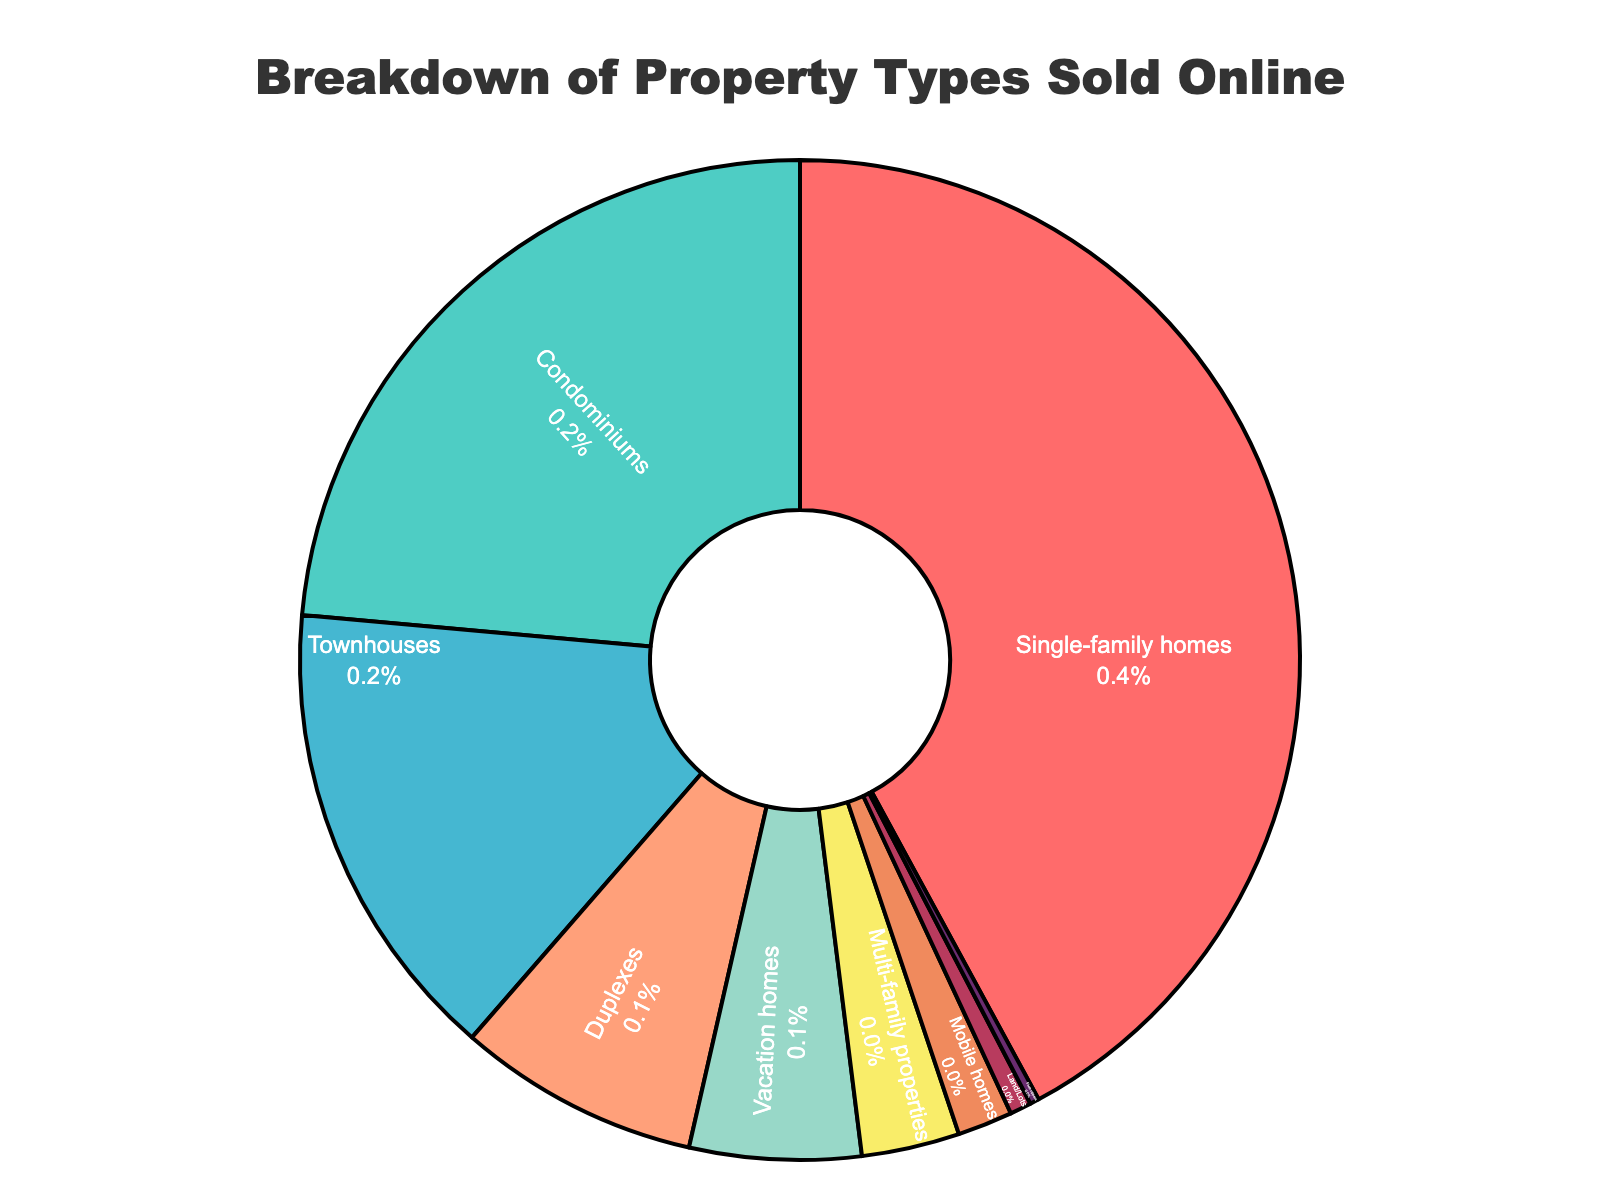What percentage of the total properties sold are Single-family homes and Townhouses combined? The percentage of Single-family homes is 42.5%, and Townhouses is 15.2%. By adding these two percentages, we get 42.5 + 15.2 = 57.7%.
Answer: 57.7% Which property type has the smallest percentage share? By looking at the pie chart, the segment for Fixer-uppers is the smallest, making it the property type with the smallest percentage share at 0.3%.
Answer: Fixer-uppers How does the percentage of Condominiums compare to that of Mobile homes? The percentage of Condominiums is 23.8%, while Mobile homes have 1.8%. Comparing these, 23.8% is significantly greater than 1.8%.
Answer: Condominiums have a higher percentage than Mobile homes What is the combined percentage of Duplexes, Vacation homes, and Multi-family properties? Duplexes represent 7.9%, Vacation homes represent 5.6%, and Multi-family properties represent 3.2%. Adding these together gives 7.9 + 5.6 + 3.2 = 16.7%.
Answer: 16.7% Which property type is represented by the blue color in the pie chart? The pie chart segments are identified by Property Types and colors. The blue segment corresponds to Condominiums.
Answer: Condominiums Do Single-family homes and Condominiums together make up more than 50% of the total properties sold? Single-family homes account for 42.5%, and Condominiums account for 23.8%. Adding these together gives 42.5 + 23.8 = 66.3%, which is more than 50%.
Answer: Yes, they make up more than 50% Which two property types have the nearest percentage values to each other? From the pie chart, Vacation homes (5.6%) and Multi-family properties (3.2%) have fairly close percentage values. However, Duplexes (7.9%) and Vacation homes (5.6%) are closer if we observe the small differences. So, (7.9 - 5.6) = 2.3% difference.
Answer: Duplexes and Vacation homes What property types are significantly under 10% in the breakdown? Property types that are significantly under 10% include: Duplexes (7.9%), Vacation homes (5.6%), Multi-family properties (3.2%), Mobile homes (1.8%), Land/Lots (0.7%), and Fixer-uppers (0.3%).
Answer: Duplexes, Vacation homes, Multi-family properties, Mobile homes, Land/Lots, Fixer-uppers Are Townhouses or Condominiums more popular based on sales percentages? The percentage for Condominiums is 23.8%, whereas Townhouses are 15.2%. Therefore, Condominiums are more popular based on sales percentages.
Answer: Condominiums are more popular What is the difference in percentage between the property type with the highest share and the property type with the lowest share? The highest share belongs to Single-family homes (42.5%) and the lowest to Fixer-uppers (0.3%). The difference is calculated as 42.5 - 0.3 = 42.2%.
Answer: 42.2% 